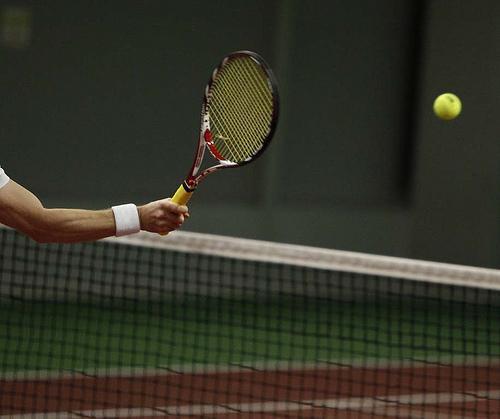How many tennis balls are in the photo?
Give a very brief answer. 1. 